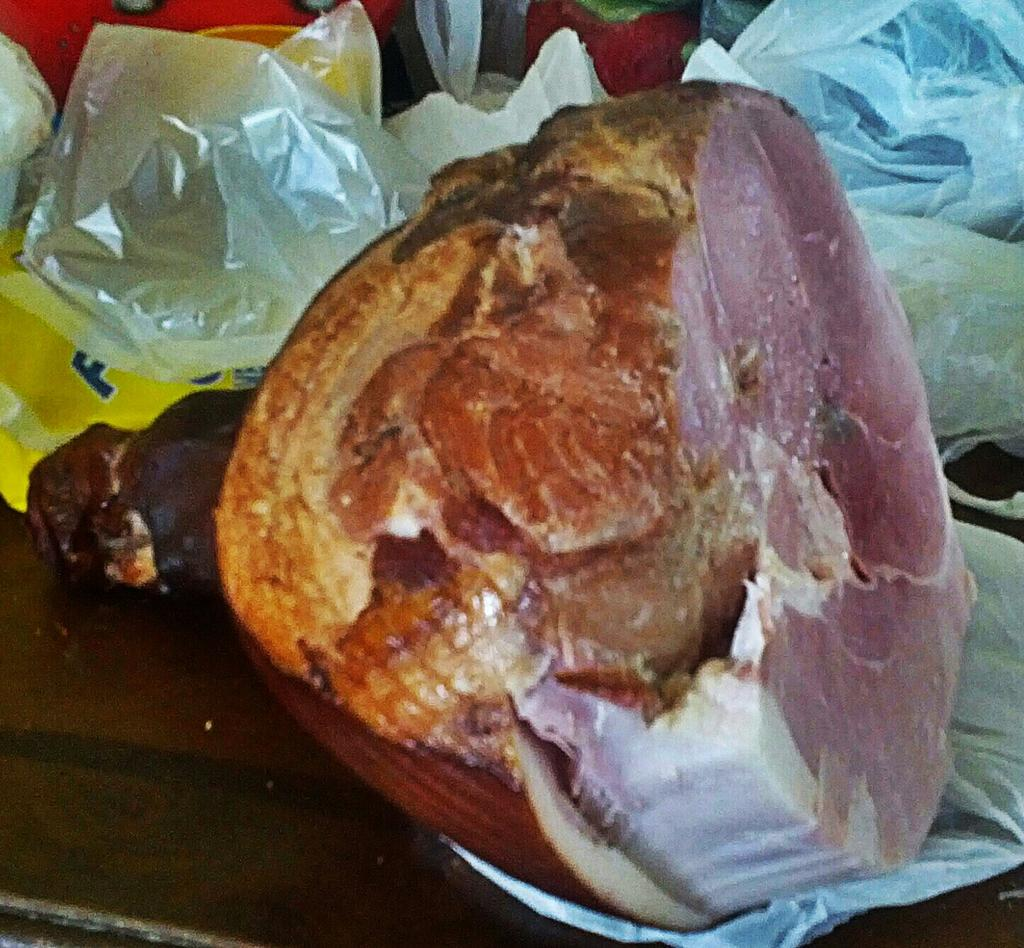What is the main subject in the center of the image? There is a piece of meat in the center of the image. What else can be seen in the background of the image? There are plastic bags in the background of the image. What type of advertisement is displayed on the piece of meat in the image? There is no advertisement present on the piece of meat in the image. 